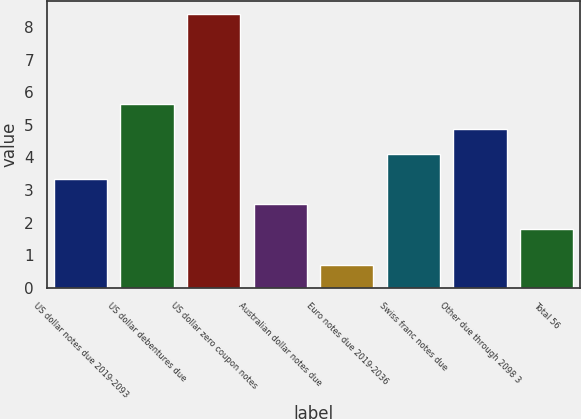Convert chart to OTSL. <chart><loc_0><loc_0><loc_500><loc_500><bar_chart><fcel>US dollar notes due 2019-2093<fcel>US dollar debentures due<fcel>US dollar zero coupon notes<fcel>Australian dollar notes due<fcel>Euro notes due 2019-2036<fcel>Swiss franc notes due<fcel>Other due through 2098 3<fcel>Total 56<nl><fcel>3.34<fcel>5.65<fcel>8.4<fcel>2.57<fcel>0.7<fcel>4.11<fcel>4.88<fcel>1.8<nl></chart> 